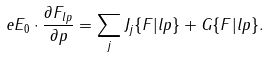<formula> <loc_0><loc_0><loc_500><loc_500>e { E _ { 0 } } \cdot \frac { \partial F _ { l { p } } } { \partial { p } } = \sum _ { j } J _ { j } \{ F | l { p } \} + G \{ F | l { p } \} .</formula> 